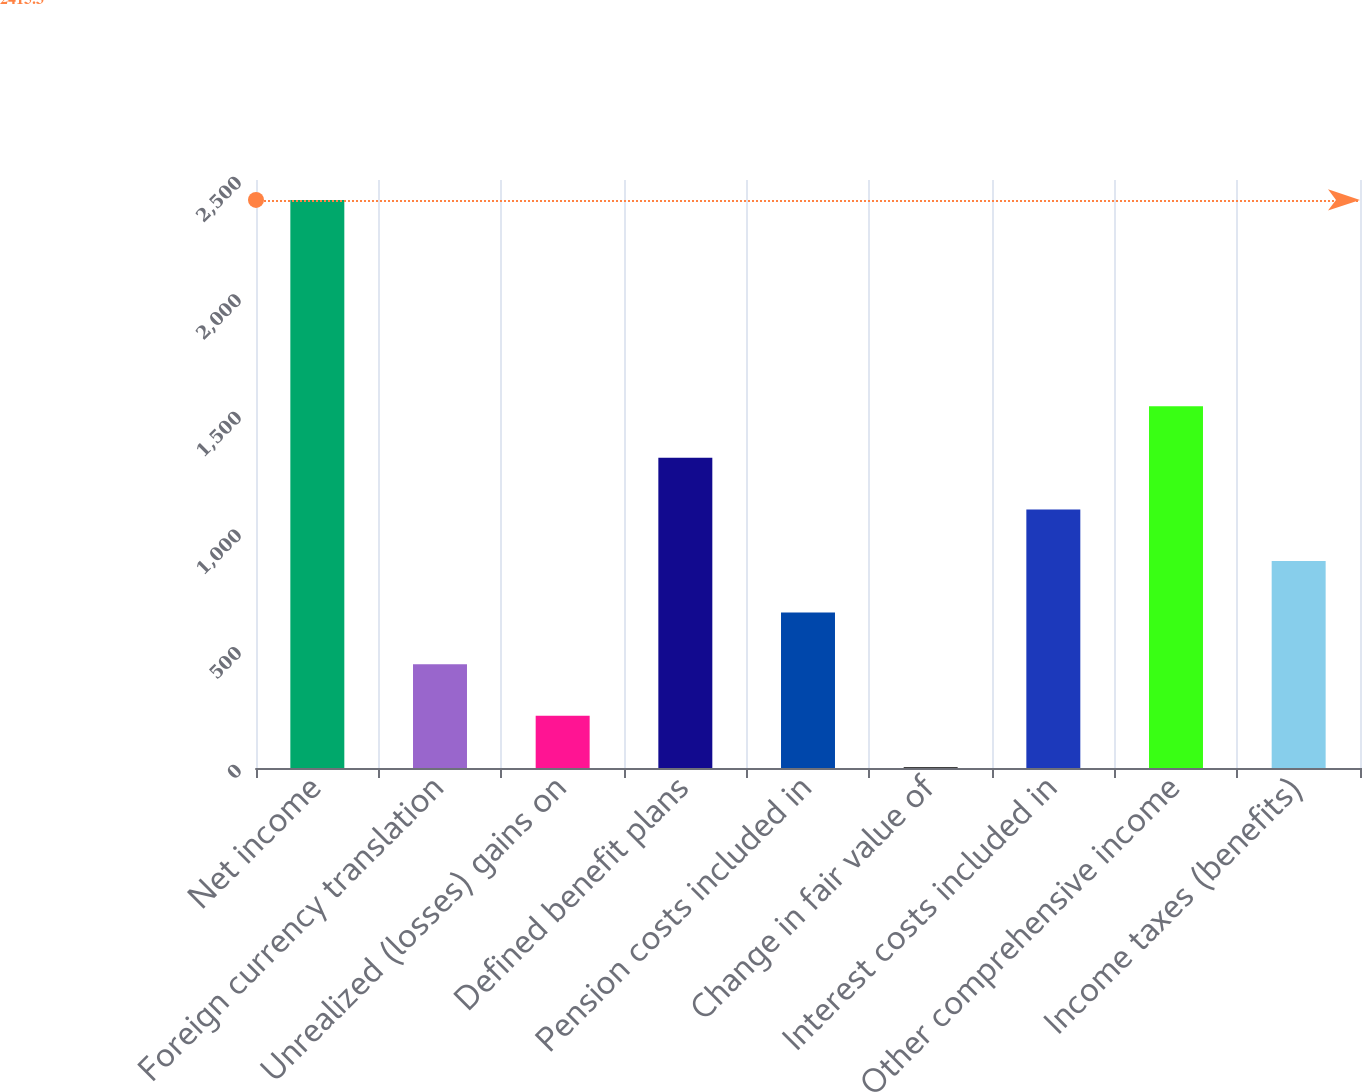<chart> <loc_0><loc_0><loc_500><loc_500><bar_chart><fcel>Net income<fcel>Foreign currency translation<fcel>Unrealized (losses) gains on<fcel>Defined benefit plans<fcel>Pension costs included in<fcel>Change in fair value of<fcel>Interest costs included in<fcel>Other comprehensive income<fcel>Income taxes (benefits)<nl><fcel>2415.3<fcel>441.6<fcel>222.3<fcel>1318.8<fcel>660.9<fcel>3<fcel>1099.5<fcel>1538.1<fcel>880.2<nl></chart> 